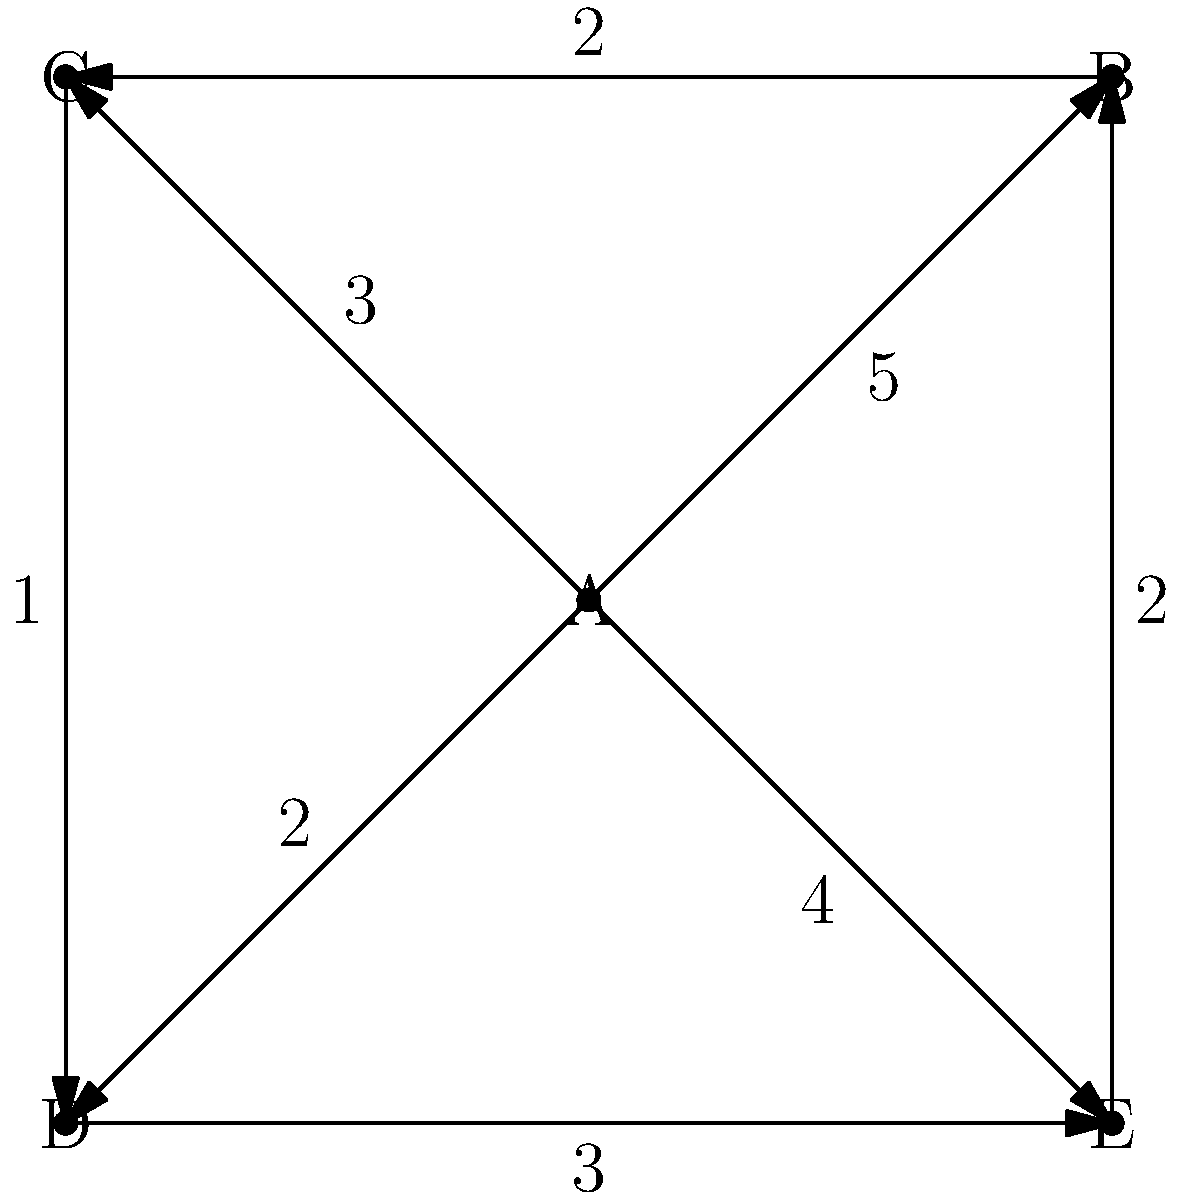As a broadcast journalism major, you're analyzing viewer engagement patterns for a news segment. The directed graph represents different segments (nodes) and viewer transitions (edges) between them. Edge weights indicate the average time (in minutes) viewers spend transitioning. What is the minimum total transition time for a viewer to experience all segments, starting and ending at segment A? To solve this problem, we need to find the shortest path that visits all nodes and returns to the starting point (A). This is known as the Traveling Salesman Problem. For this small graph, we can solve it step-by-step:

1. Start at A and list all possible paths:
   - A → B → C → D → E → A
   - A → B → E → D → C → A
   - A → C → D → E → B → A
   - A → D → E → B → C → A
   - A → E → B → C → D → A

2. Calculate the total weight for each path:
   - A → B (5) → C (2) → D (1) → E (3) → A (4) = 15 minutes
   - A → B (5) → E (2) → D (3) → C (1) → A (3) = 14 minutes
   - A → C (3) → D (1) → E (3) → B (2) → A (5) = 14 minutes
   - A → D (2) → E (3) → B (2) → C (2) → A (3) = 12 minutes
   - A → E (4) → B (2) → C (2) → D (1) → A (2) = 11 minutes

3. The minimum total transition time is the smallest sum, which is 11 minutes.

This path (A → E → B → C → D → A) allows a viewer to experience all segments with the least total transition time.
Answer: 11 minutes 